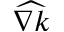Convert formula to latex. <formula><loc_0><loc_0><loc_500><loc_500>\widehat { \nabla k }</formula> 